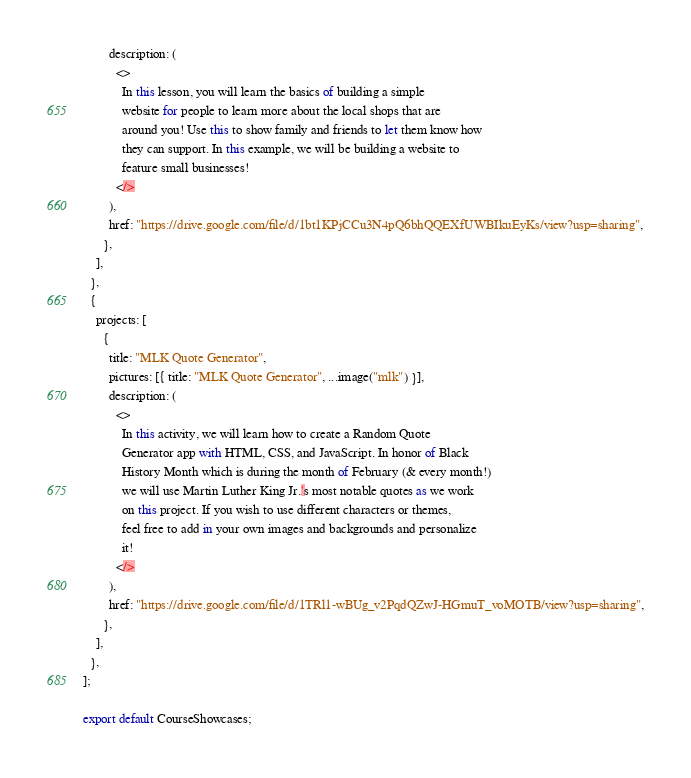<code> <loc_0><loc_0><loc_500><loc_500><_TypeScript_>        description: (
          <>
            In this lesson, you will learn the basics of building a simple
            website for people to learn more about the local shops that are
            around you! Use this to show family and friends to let them know how
            they can support. In this example, we will be building a website to
            feature small businesses!
          </>
        ),
        href: "https://drive.google.com/file/d/1bt1KPjCCu3N4pQ6bhQQEXfUWBIkuEyKs/view?usp=sharing",
      },
    ],
  },
  {
    projects: [
      {
        title: "MLK Quote Generator",
        pictures: [{ title: "MLK Quote Generator", ...image("mlk") }],
        description: (
          <>
            In this activity, we will learn how to create a Random Quote
            Generator app with HTML, CSS, and JavaScript. In honor of Black
            History Month which is during the month of February (& every month!)
            we will use Martin Luther King Jr.'s most notable quotes as we work
            on this project. If you wish to use different characters or themes,
            feel free to add in your own images and backgrounds and personalize
            it!
          </>
        ),
        href: "https://drive.google.com/file/d/1TRl1-wBUg_v2PqdQZwJ-HGmuT_voMOTB/view?usp=sharing",
      },
    ],
  },
];

export default CourseShowcases;
</code> 